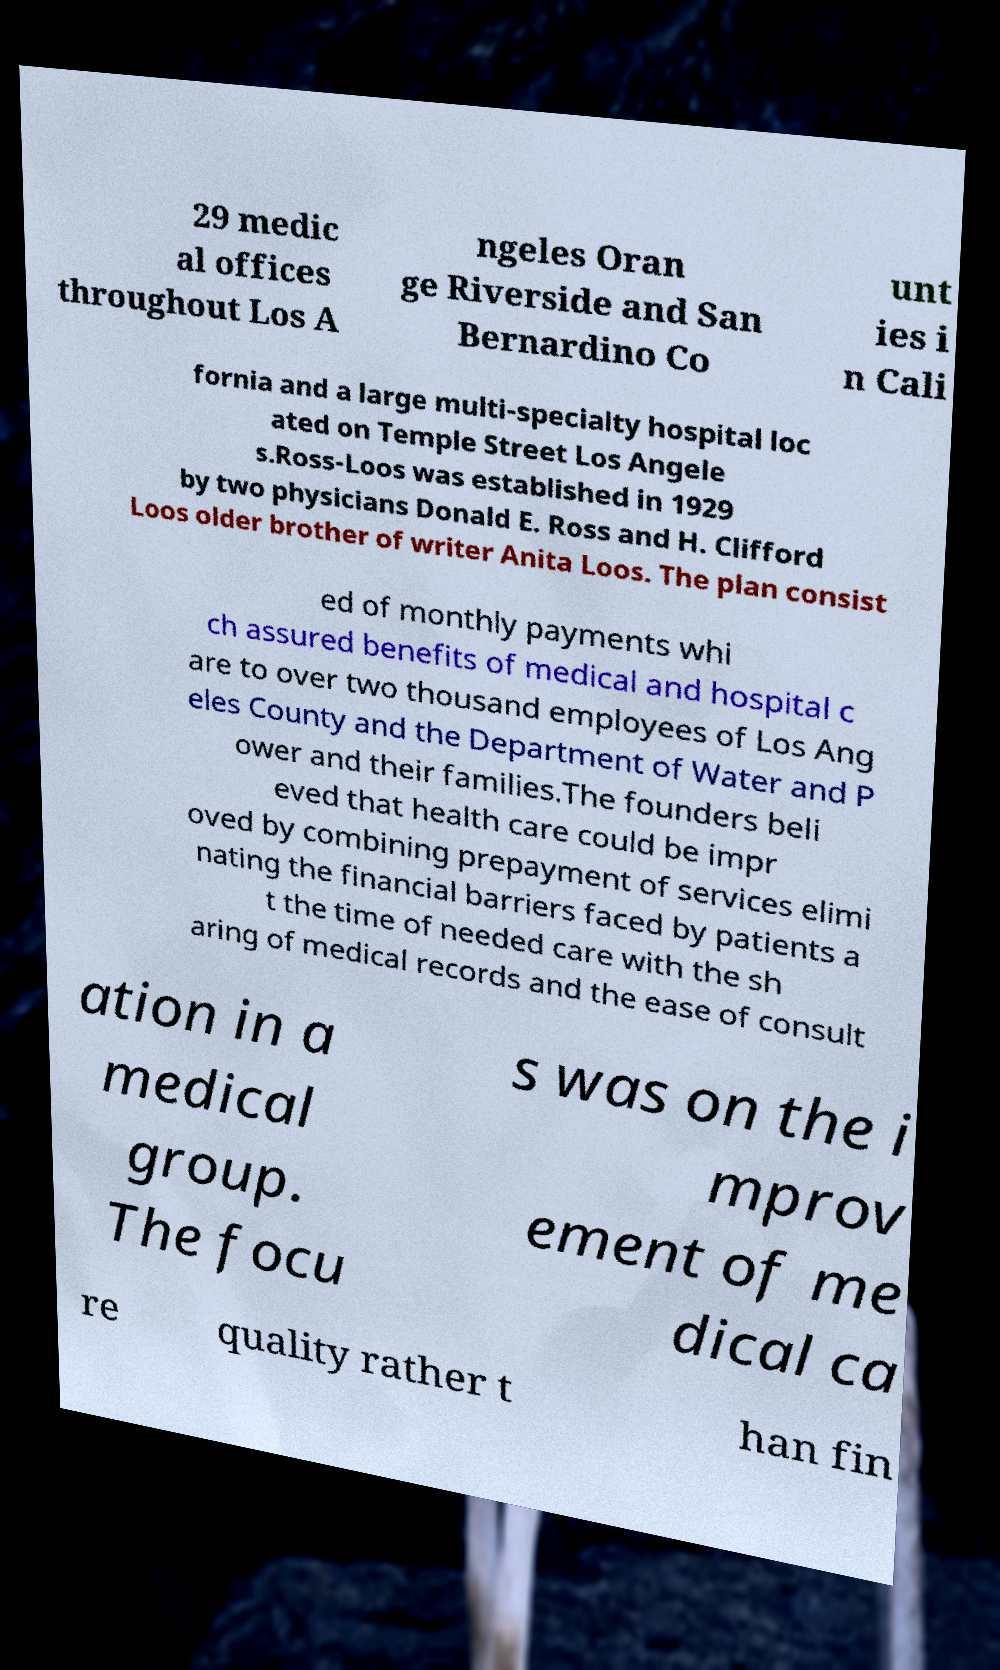Could you assist in decoding the text presented in this image and type it out clearly? 29 medic al offices throughout Los A ngeles Oran ge Riverside and San Bernardino Co unt ies i n Cali fornia and a large multi-specialty hospital loc ated on Temple Street Los Angele s.Ross-Loos was established in 1929 by two physicians Donald E. Ross and H. Clifford Loos older brother of writer Anita Loos. The plan consist ed of monthly payments whi ch assured benefits of medical and hospital c are to over two thousand employees of Los Ang eles County and the Department of Water and P ower and their families.The founders beli eved that health care could be impr oved by combining prepayment of services elimi nating the financial barriers faced by patients a t the time of needed care with the sh aring of medical records and the ease of consult ation in a medical group. The focu s was on the i mprov ement of me dical ca re quality rather t han fin 